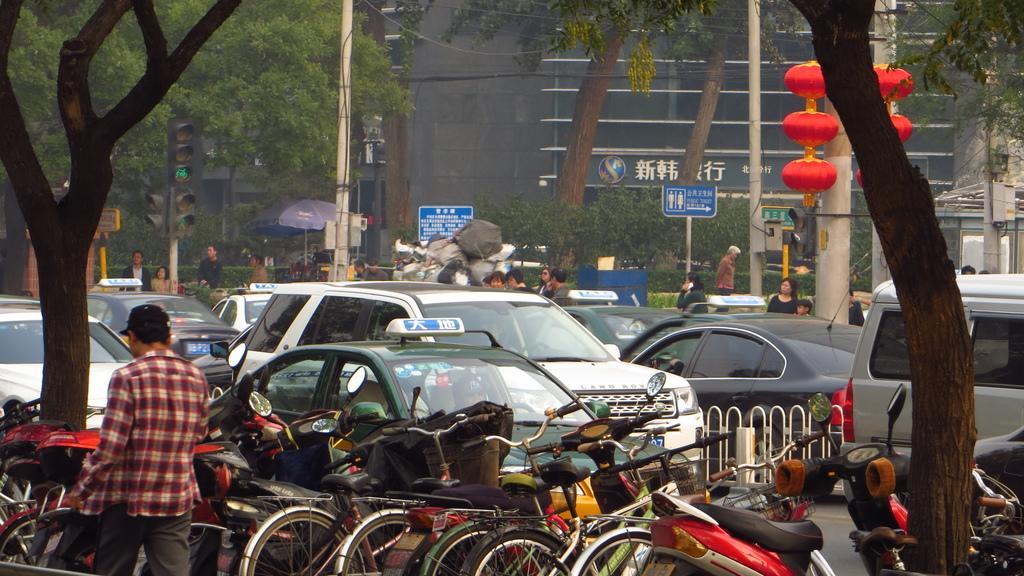Can you describe this image briefly? There is a man walking and we can see vehicles,fence and trees. In the background we can see people,traffic signals and boards on poles,trees and building. 